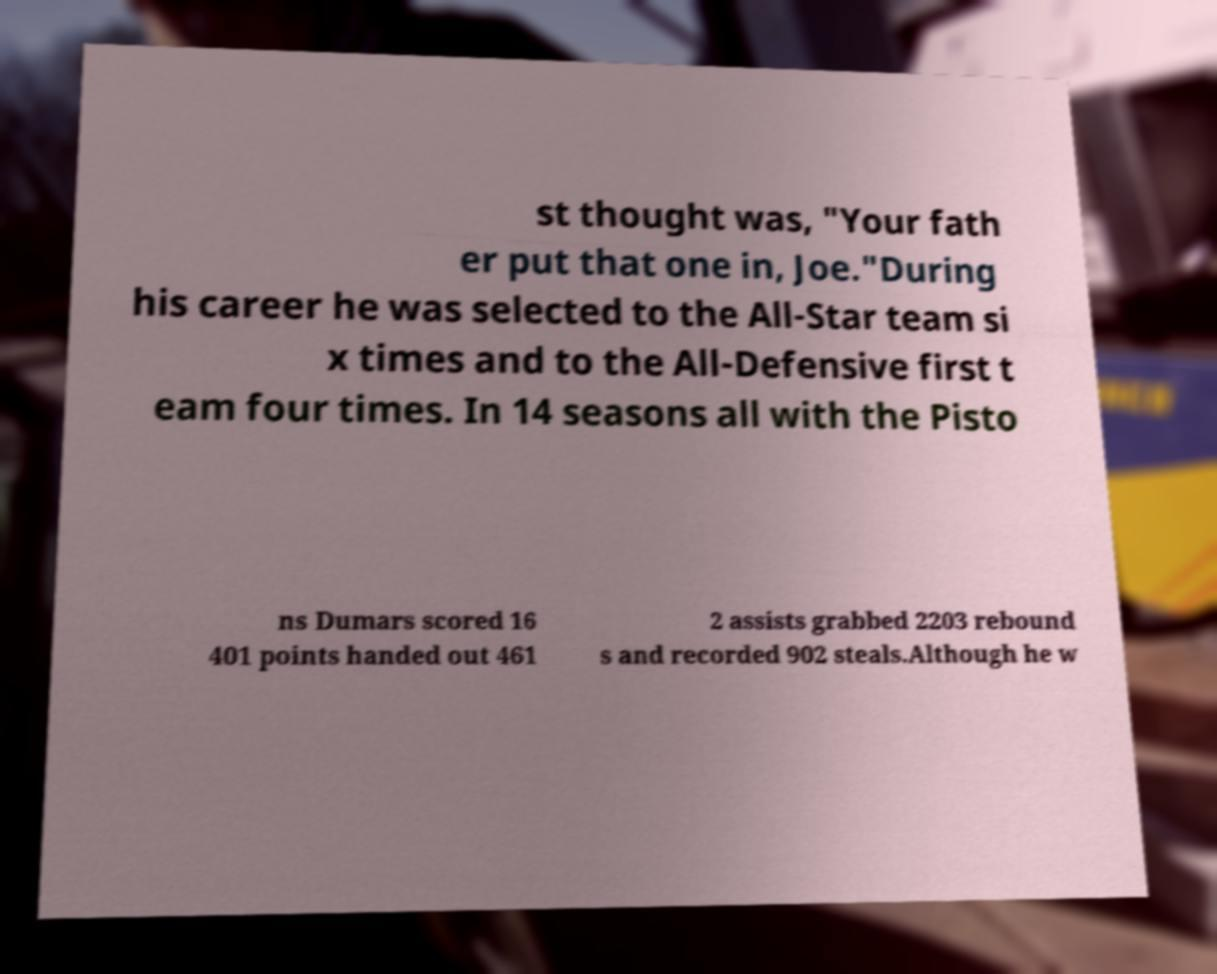For documentation purposes, I need the text within this image transcribed. Could you provide that? st thought was, "Your fath er put that one in, Joe."During his career he was selected to the All-Star team si x times and to the All-Defensive first t eam four times. In 14 seasons all with the Pisto ns Dumars scored 16 401 points handed out 461 2 assists grabbed 2203 rebound s and recorded 902 steals.Although he w 